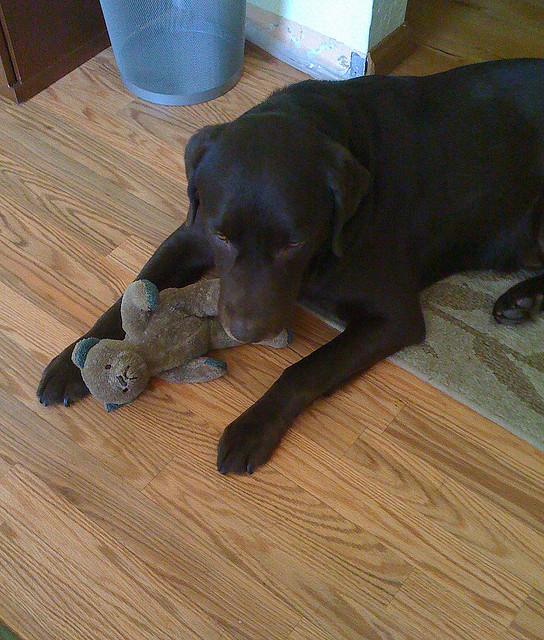What does the dog have?
Concise answer only. Teddy bear. Is that a black teddy bear?
Write a very short answer. No. What is the blue object in the background?
Quick response, please. Trash can. 